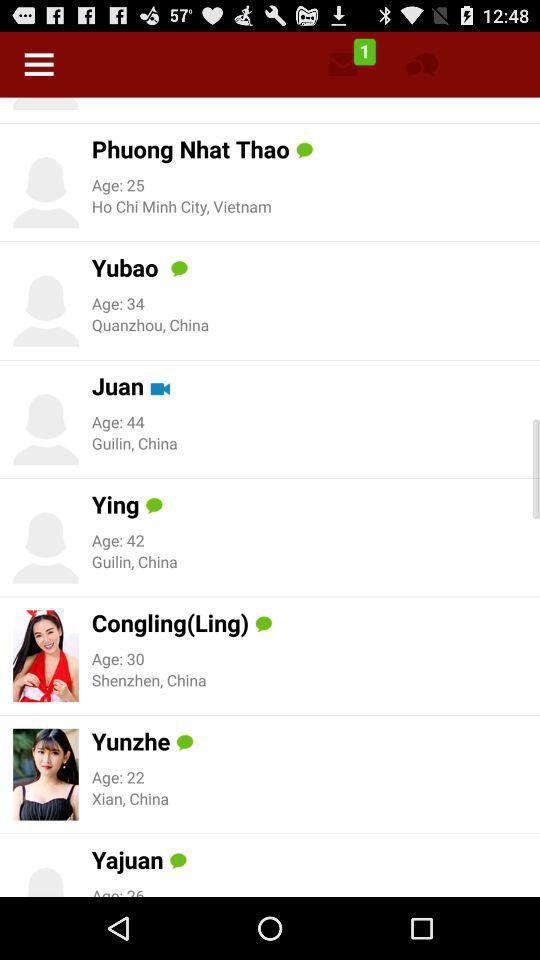How many unread messages are there? There is 1 unread message. 